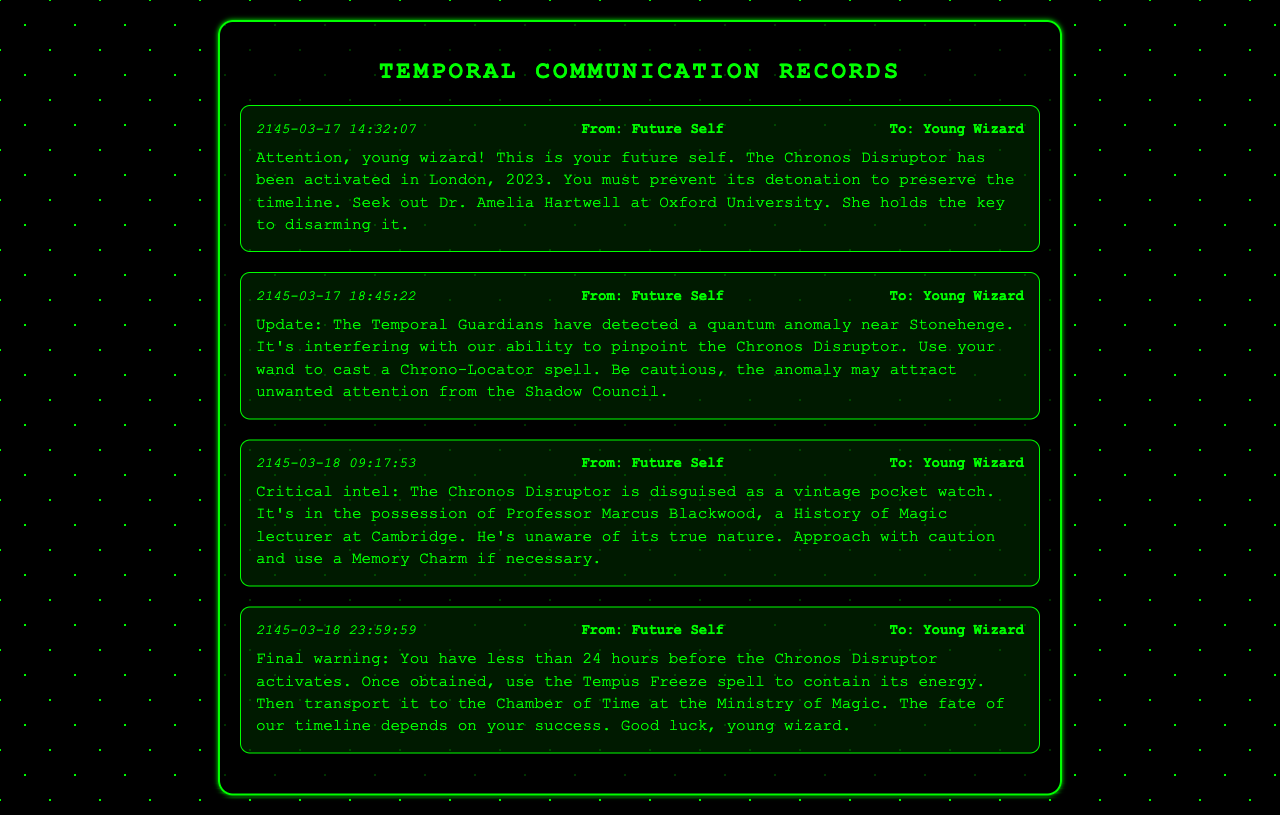what is the date of the first message? The first message was sent on 2145-03-17.
Answer: 2145-03-17 who is the sender of all messages? Each message is sent by "Future Self."
Answer: Future Self what is the name of the key individual mentioned in the first message? The first message advises to seek out Dr. Amelia Hartwell.
Answer: Dr. Amelia Hartwell what is the object disguised as the Chronos Disruptor? The Chronos Disruptor is disguised as a vintage pocket watch.
Answer: vintage pocket watch how long do you have to stop the Chronos Disruptor as stated in the final message? The final message warns that there are less than 24 hours left.
Answer: less than 24 hours what spell should be cast near Stonehenge? The message advises to cast a Chrono-Locator spell.
Answer: Chrono-Locator what location is mentioned as the destination for the items? The destination for the items is the Chamber of Time at the Ministry of Magic.
Answer: Chamber of Time who possesses the Chronos Disruptor? Professor Marcus Blackwood has the Chronos Disruptor.
Answer: Professor Marcus Blackwood what is the consequence of not preventing the Chronos Disruptor's activation? The messages imply that failing to act will jeopardize the timeline.
Answer: jeopardize the timeline 